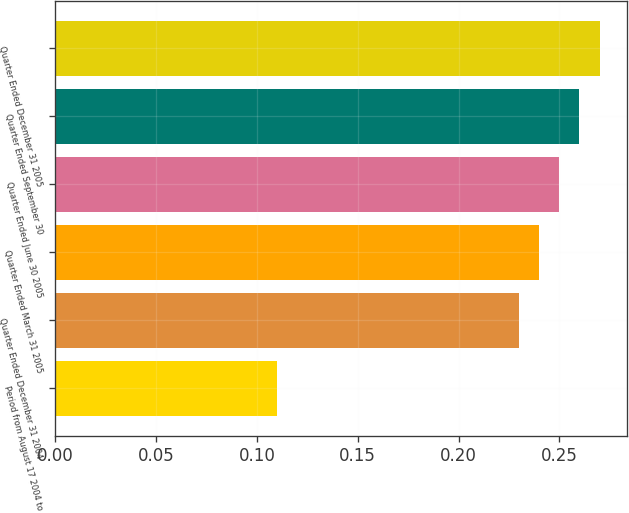<chart> <loc_0><loc_0><loc_500><loc_500><bar_chart><fcel>Period from August 17 2004 to<fcel>Quarter Ended December 31 2004<fcel>Quarter Ended March 31 2005<fcel>Quarter Ended June 30 2005<fcel>Quarter Ended September 30<fcel>Quarter Ended December 31 2005<nl><fcel>0.11<fcel>0.23<fcel>0.24<fcel>0.25<fcel>0.26<fcel>0.27<nl></chart> 